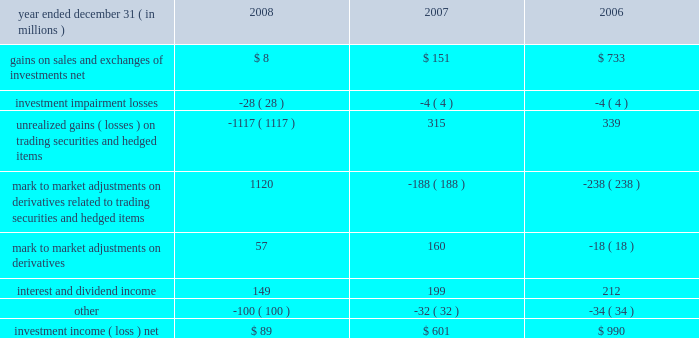Llc 201d ) , that will focus on the deployment of a nationwide 4g wire- less network .
We , together with the other members of the investor group , have invested $ 3.2 billion in clearwire llc .
Our portion of the investment was $ 1.05 billion .
As a result of our investment , we received ownership units ( 201cownership units 201d ) of clearwire llc and class b stock ( 201cvoting stock 201d ) of clearwire corporation , the pub- licly traded holding company that controls clearwire llc .
The voting stock has voting rights equal to those of the publicly traded class a stock of clearwire corporation , but has only minimal economic rights .
We hold our economic rights through the owner- ship units , which have limited voting rights .
One ownership unit combined with one share of voting stock are exchangeable into one share of clearwire corporation 2019s publicly traded class a stock .
At closing , we received 52.5 million ownership units and 52.5 million shares of voting stock , which represents an approx- imate 7% ( 7 % ) ownership interest on a fully diluted basis .
During the first quarter of 2009 , the purchase price per share is expected to be adjusted based on the trading prices of clearwire corporation 2019s publicly traded class a stock .
After the post-closing adjustment , we anticipate that we will have an approximate 8% ( 8 % ) ownership interest on a fully diluted basis .
In connection with the clearwire transaction , we entered into an agreement with sprint that allows us to offer wireless services utilizing certain of sprint 2019s existing wireless networks and an agreement with clearwire llc that allows us to offer wireless serv- ices utilizing clearwire 2019s next generation wireless broadband network .
We allocated a portion of our $ 1.05 billion investment to the related agreements .
We will account for our investment under the equity method and record our share of net income or loss one quarter in arrears .
Clearwire llc is expected to incur losses in the early years of operation , which under the equity method of accounting , will be reflected in our future operating results and reduce the cost basis of our investment .
We evaluated our investment at december 31 , 2008 to determine if an other than temporary decline in fair value below our cost basis had occurred .
The primary input in estimating the fair value of our investment was the quoted market value of clearwire publicly traded class a shares at december 31 , 2008 , which declined significantly from the date of our initial agreement in may 2008 .
As a result of the severe decline in the quoted market value , we recognized an impairment in other income ( expense ) of $ 600 million to adjust our cost basis in our investment to its esti- mated fair value .
In the future , our evaluation of other than temporary declines in fair value of our investment will include a comparison of actual operating results and updated forecasts to the projected discounted cash flows that were used in making our initial investment decision , other impairment indicators , such as changes in competition or technology , as well as a comparison to the value that would be obtained by exchanging our investment into clearwire corporation 2019s publicly traded class a shares .
Cost method airtouch communications , inc .
We hold two series of preferred stock of airtouch communica- tions , inc .
( 201cairtouch 201d ) , a subsidiary of vodafone , which are redeemable in april 2020 .
As of december 31 , 2008 and 2007 , the airtouch preferred stock was recorded at $ 1.479 billion and $ 1.465 billion , respectively .
As of december 31 , 2008 , the estimated fair value of the airtouch preferred stock was $ 1.357 billion , which is below our carrying amount .
The recent decline in fair value is attributable to changes in interest rates .
We have determined this decline to be temporary .
The factors considered were the length of time and the extent to which the market value has been less than cost , the credit rating of airtouch , and our intent and ability to retain the investment for a period of time sufficient to allow for recovery .
Specifically , we expect to hold the two series of airtouch preferred stock until their redemption in 2020 .
The dividend and redemption activity of the airtouch preferred stock determines the dividend and redemption payments asso- ciated with substantially all of the preferred shares issued by one of our consolidated subsidiaries , which is a vie .
The subsidiary has three series of preferred stock outstanding with an aggregate redemption value of $ 1.750 billion .
Substantially all of the preferred shares are redeemable in april 2020 at a redemption value of $ 1.650 billion .
As of december 31 , 2008 and 2007 , the two redeemable series of subsidiary preferred shares were recorded at $ 1.468 billion and $ 1.465 billion , respectively , and those amounts are included in other noncurrent liabilities .
The one nonredeemable series of subsidiary preferred shares was recorded at $ 100 million as of both december 31 , 2008 and 2007 and those amounts are included in minority interest on our consolidated balance sheet .
Investment income ( loss ) , net .
55 comcast 2008 annual report on form 10-k .
What was the percent of our investment in clearwire compared to other investors? 
Computations: (1.05 / 3.2)
Answer: 0.32812. 